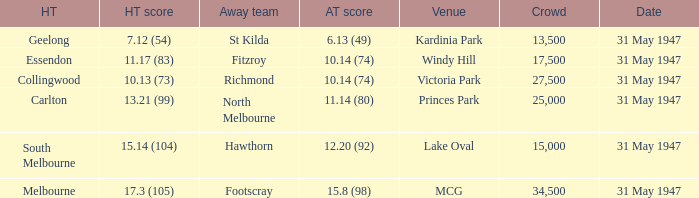What is the home team's score at mcg? 17.3 (105). 